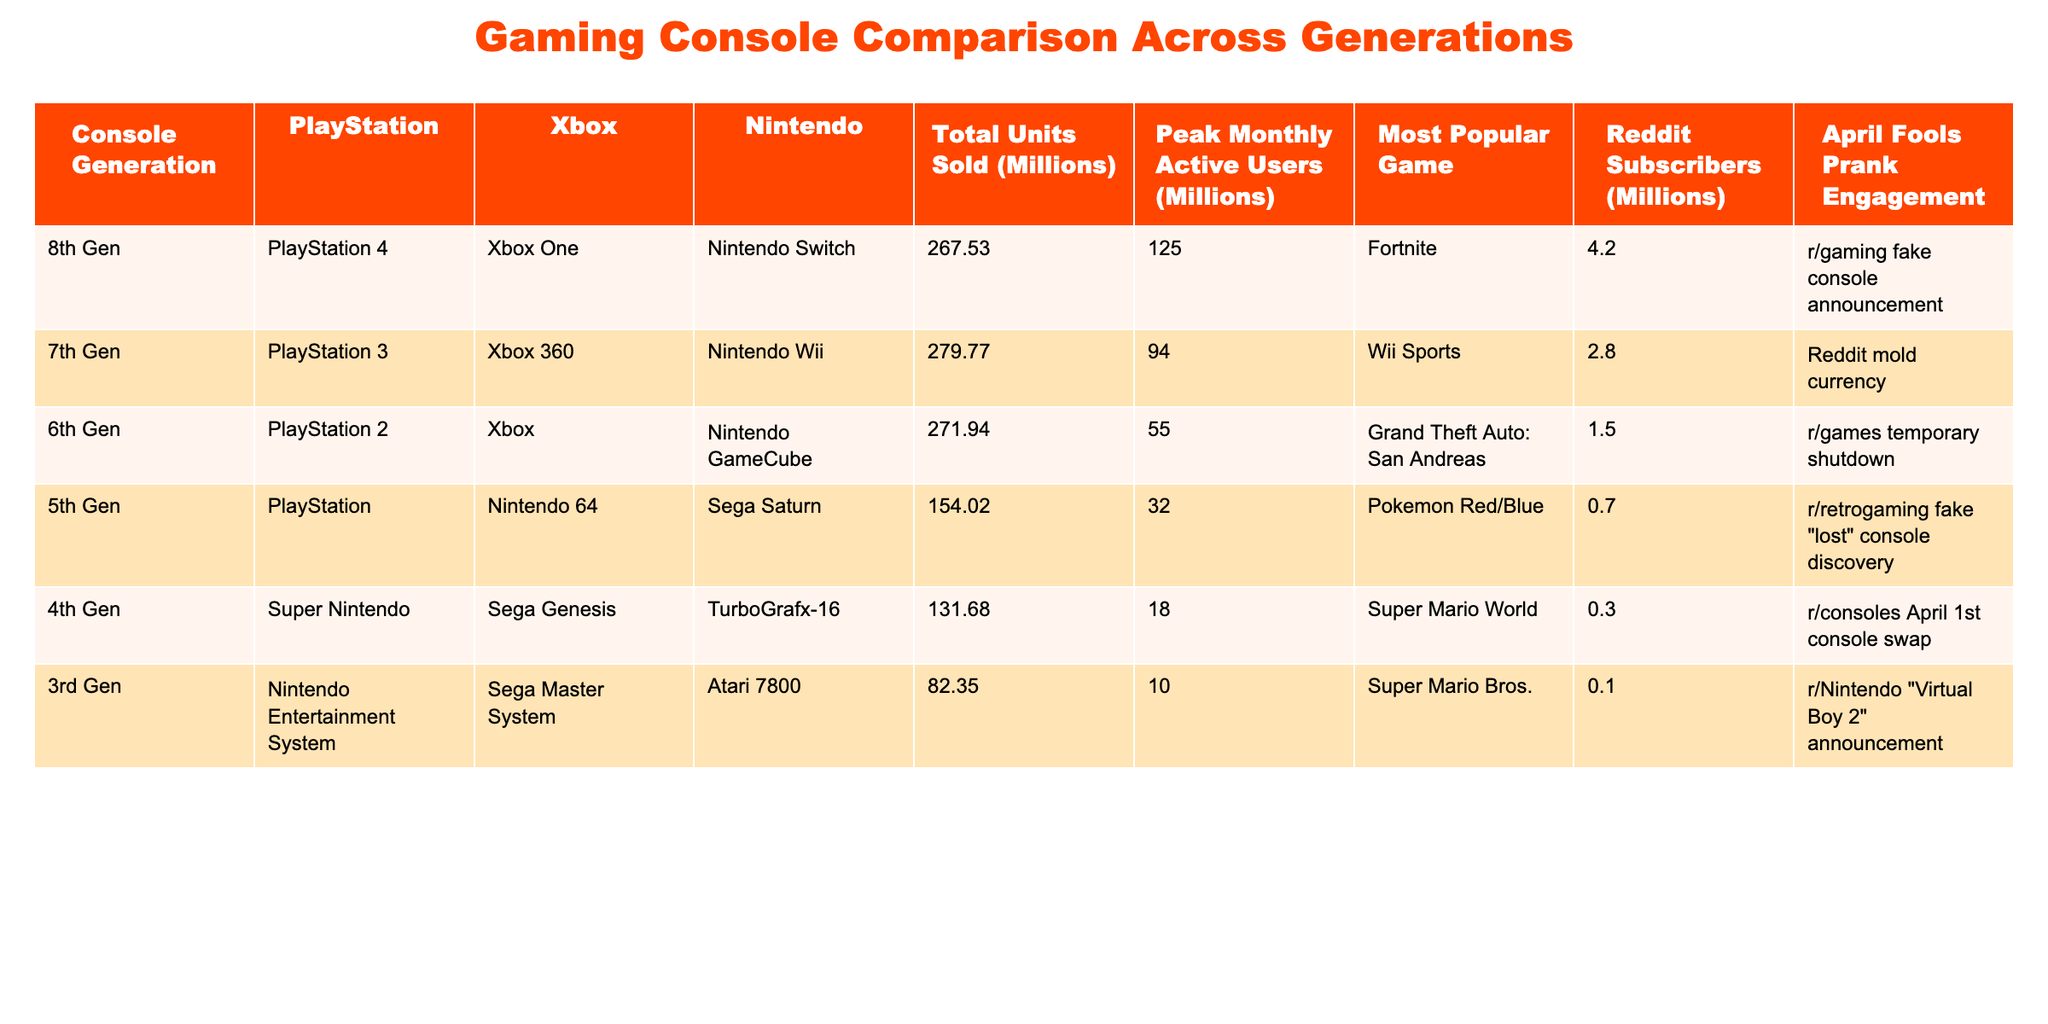What is the total units sold for the PlayStation 4? The table indicates that the total units sold for the PlayStation 4 is listed in the column for the 8th generation, which shows 267.53 million.
Answer: 267.53 million Which console has the highest peak monthly active users? By examining the "Peak Monthly Active Users" column, the highest value is 125 million for the PlayStation 4 in the 8th generation.
Answer: PlayStation 4 What is the total number of units sold across all generations for Nintendo? To calculate the total units sold for Nintendo, we gather the values from the Nintendo column: 114.94 million (Switch) + 101.63 million (Wii) + 21.74 million (GameCube) + 32.93 million (Nintendo 64) + 0 (other generations) = 270.24 million.
Answer: 270.24 million Is the engagement from Reddit subscribers higher for 6th Gen or 5th Gen consoles? Comparing the Reddit Subscribers column, 6th Gen has 1.5 million and 5th Gen has 0.7 million, therefore, engagement is higher for 6th Gen.
Answer: Yes What is the difference in total units sold between the 7th Gen and 5th Gen consoles? The total units sold for the 7th Gen is 279.77 million and for the 5th Gen is 154.02 million. The difference is calculated as 279.77 - 154.02 = 125.75 million.
Answer: 125.75 million What is the average peak monthly active users for consoles from the 4th Gen and earlier? The peak monthly active users for the relevant generations are 18 million (4th Gen), 10 million (3rd Gen), and 55 million (6th Gen), so the average is (18 + 10 + 55) / 3 = 27.67 million.
Answer: 27.67 million Which generation had the most popular game "Wii Sports"? "Wii Sports" is listed under the 7th Generation, as seen in the Most Popular Game column.
Answer: 7th Generation How many more Reddit subscribers does the 8th Gen have compared to the 3rd Gen? The Reddit subscribers for the 8th Gen are 4.2 million and for the 3rd Gen are 0.1 million; therefore, the difference is 4.2 - 0.1 = 4.1 million.
Answer: 4.1 million Is the April Fools' prank engagement for 4th Gen consoles higher than for the 5th Gen? The prank engagement for the 4th Gen is noted as 'r/consoles April 1st console swap' and for the 5th Gen is 'r/retrogaming fake "lost" console discovery'. Both do not provide a numerical value, but it's evident that 4th Gen has a more engaging prank.
Answer: Yes What is the median peak monthly active users across all generations? First, list the active user counts: 125 (8th Gen), 94 (7th Gen), 55 (6th Gen), 32 (5th Gen), 18 (4th Gen), 10 (3rd Gen). The median is calculated as the average of the two middle values (55 and 32) = (55 + 32) / 2 = 43.5 million.
Answer: 43.5 million 